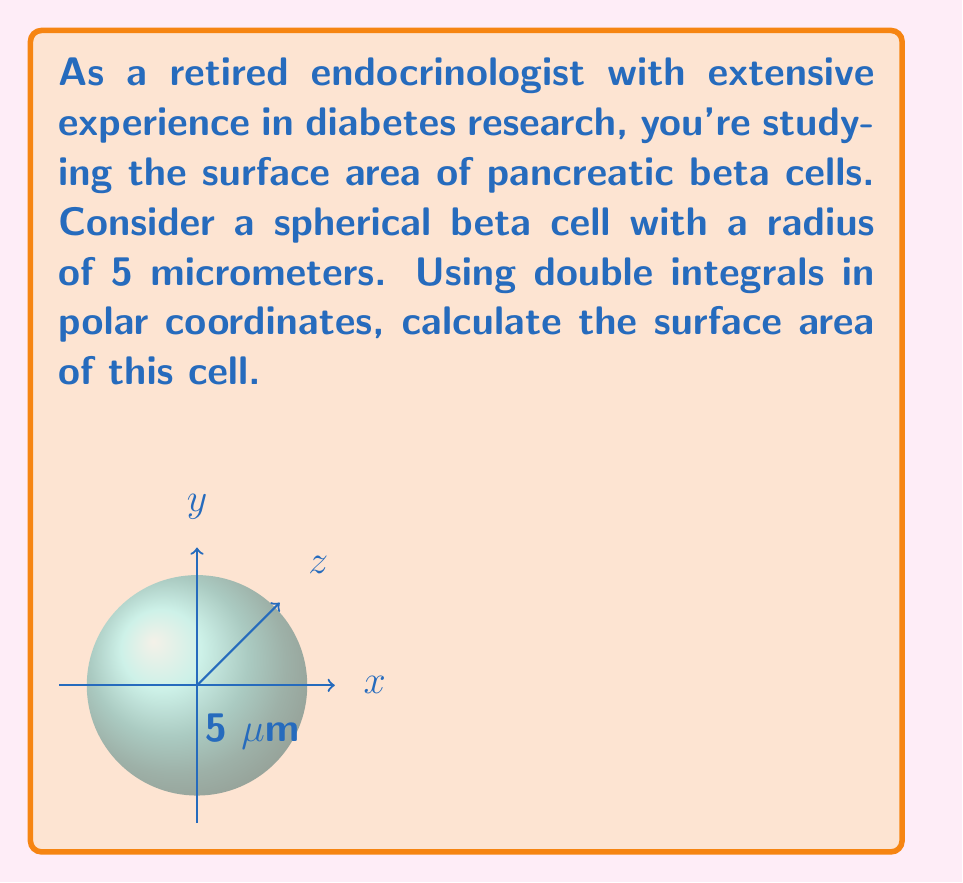Provide a solution to this math problem. Let's approach this step-by-step:

1) The surface area of a sphere in Cartesian coordinates is given by:

   $$A = \iint_S dS = \iint_S \sqrt{1 + (\frac{\partial z}{\partial x})^2 + (\frac{\partial z}{\partial y})^2} dxdy$$

2) For a sphere of radius $R$, we have the equation:

   $$x^2 + y^2 + z^2 = R^2$$

3) Solving for $z$:

   $$z = \sqrt{R^2 - x^2 - y^2}$$

4) Computing partial derivatives:

   $$\frac{\partial z}{\partial x} = \frac{-x}{\sqrt{R^2 - x^2 - y^2}}$$
   $$\frac{\partial z}{\partial y} = \frac{-y}{\sqrt{R^2 - x^2 - y^2}}$$

5) Substituting into the surface area formula:

   $$A = \iint_S \sqrt{1 + \frac{x^2}{R^2 - x^2 - y^2} + \frac{y^2}{R^2 - x^2 - y^2}} dxdy$$

6) Simplifying:

   $$A = \iint_S \sqrt{\frac{R^2}{R^2 - x^2 - y^2}} dxdy = \iint_S \frac{R}{\sqrt{R^2 - x^2 - y^2}} dxdy$$

7) Now, let's switch to polar coordinates:
   $x = r\cos\theta$, $y = r\sin\theta$, $dxdy = rdrd\theta$

   $$A = \int_0^{2\pi} \int_0^R \frac{R}{\sqrt{R^2 - r^2}} rdrd\theta$$

8) The $\theta$ integral goes from 0 to $2\pi$, and $r$ goes from 0 to $R$. Evaluating:

   $$A = 2\pi R \int_0^R \frac{r}{\sqrt{R^2 - r^2}} dr$$

9) This integral can be solved by substitution. Let $u = R^2 - r^2$, then $du = -2rdr$:

   $$A = -\pi R \int_{R^2}^0 \frac{du}{\sqrt{u}} = -2\pi R [2\sqrt{u}]_0^{R^2} = 4\pi R^2$$

10) For our beta cell, $R = 5$ micrometers. Substituting:

    $$A = 4\pi(5^2) = 100\pi \text{ square micrometers}$$
Answer: $100\pi \text{ μm}^2$ 